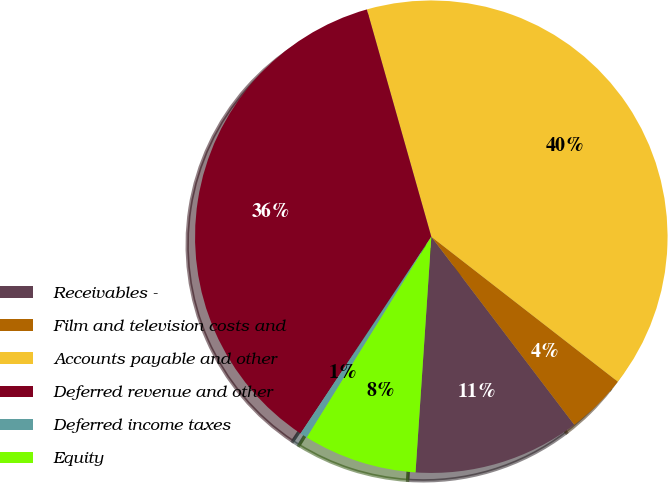<chart> <loc_0><loc_0><loc_500><loc_500><pie_chart><fcel>Receivables -<fcel>Film and television costs and<fcel>Accounts payable and other<fcel>Deferred revenue and other<fcel>Deferred income taxes<fcel>Equity<nl><fcel>11.41%<fcel>4.14%<fcel>39.91%<fcel>36.27%<fcel>0.5%<fcel>7.77%<nl></chart> 